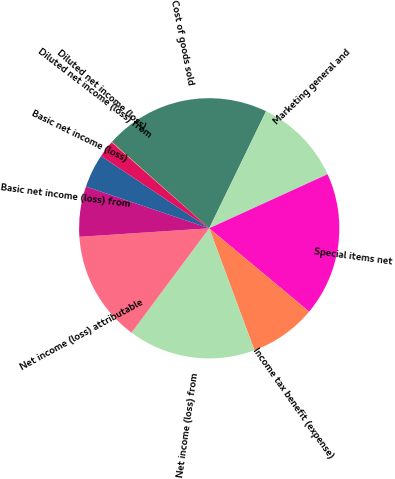Convert chart to OTSL. <chart><loc_0><loc_0><loc_500><loc_500><pie_chart><fcel>Cost of goods sold<fcel>Marketing general and<fcel>Special items net<fcel>Income tax benefit (expense)<fcel>Net income (loss) from<fcel>Net income (loss) attributable<fcel>Basic net income (loss) from<fcel>Basic net income (loss)<fcel>Diluted net income (loss) from<fcel>Diluted net income (loss)<nl><fcel>20.64%<fcel>10.98%<fcel>17.88%<fcel>8.29%<fcel>15.83%<fcel>13.77%<fcel>6.24%<fcel>4.18%<fcel>2.12%<fcel>0.06%<nl></chart> 